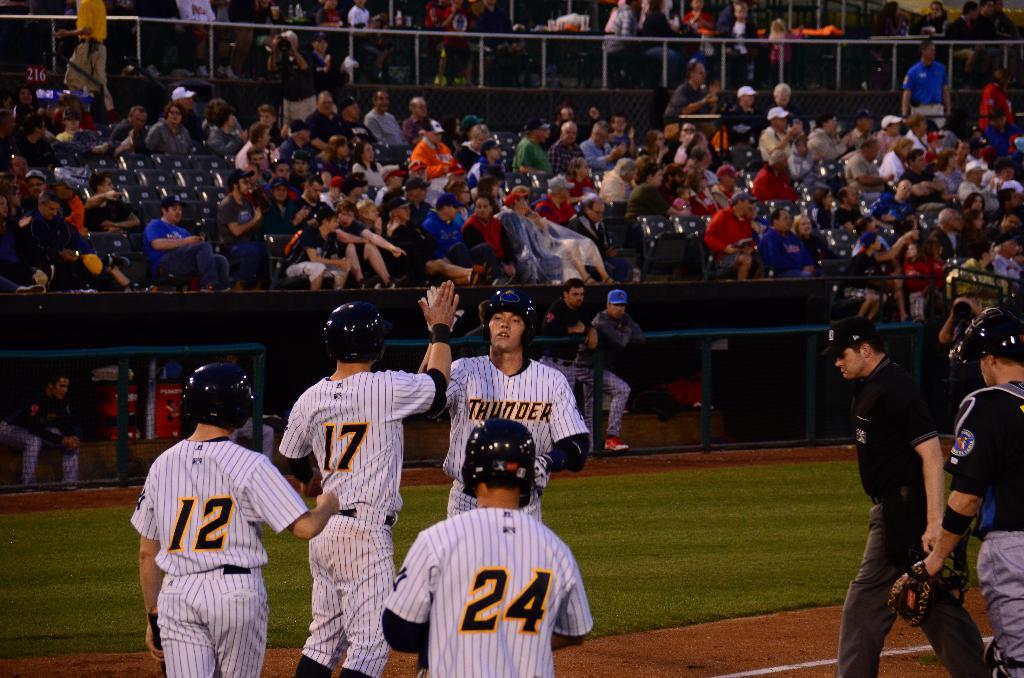What team are these players for?
Offer a very short reply. Thunder. Who are these players?
Ensure brevity in your answer.  Thunder. 